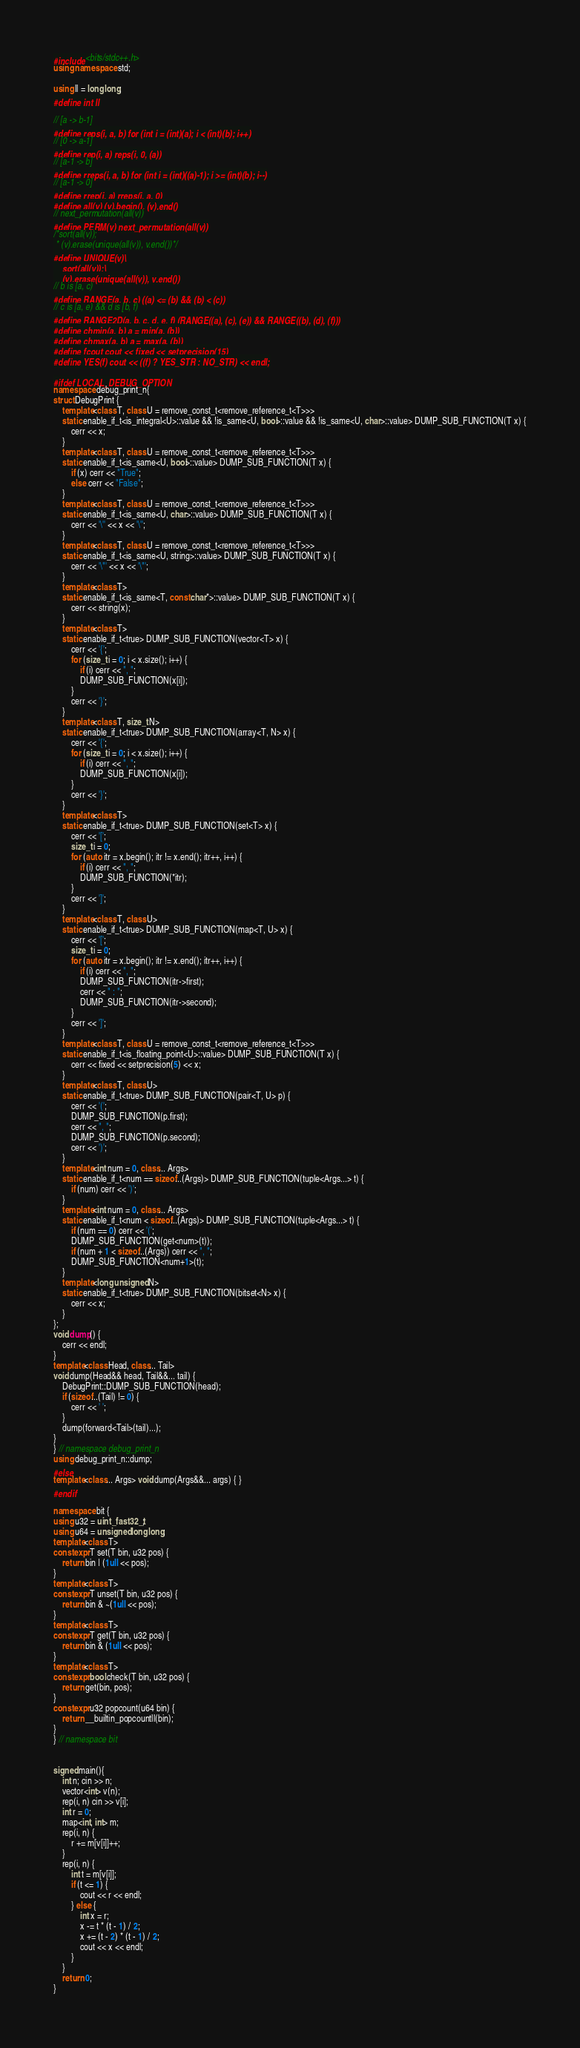Convert code to text. <code><loc_0><loc_0><loc_500><loc_500><_C++_>#include <bits/stdc++.h>
using namespace std;

using ll = long long;
#define int ll

// [a -> b-1]
#define reps(i, a, b) for (int i = (int)(a); i < (int)(b); i++)
// [0 -> a-1]
#define rep(i, a) reps(i, 0, (a))
// [a-1 -> b]
#define rreps(i, a, b) for (int i = (int)((a)-1); i >= (int)(b); i--)
// [a-1 -> 0]
#define rrep(i, a) rreps(i, a, 0)
#define all(v) (v).begin(), (v).end()
// next_permutation(all(v))
#define PERM(v) next_permutation(all(v))
/*sort(all(v));
 * (v).erase(unique(all(v)), v.end())*/
#define UNIQUE(v)\
	sort(all(v));\
	(v).erase(unique(all(v)), v.end())
// b is [a, c)
#define RANGE(a, b, c) ((a) <= (b) && (b) < (c))
// c is [a, e) && d is [b, f)
#define RANGE2D(a, b, c, d, e, f) (RANGE((a), (c), (e)) && RANGE((b), (d), (f)))
#define chmin(a, b) a = min(a, (b))
#define chmax(a, b) a = max(a, (b))
#define fcout cout << fixed << setprecision(15)
#define YES(f) cout << ((f) ? YES_STR : NO_STR) << endl;

#ifdef LOCAL_DEBUG_OPTION
namespace debug_print_n{
struct DebugPrint {
	template<class T, class U = remove_const_t<remove_reference_t<T>>>
	static enable_if_t<is_integral<U>::value && !is_same<U, bool>::value && !is_same<U, char>::value> DUMP_SUB_FUNCTION(T x) {
		cerr << x;
	}
	template<class T, class U = remove_const_t<remove_reference_t<T>>>
	static enable_if_t<is_same<U, bool>::value> DUMP_SUB_FUNCTION(T x) {
		if (x) cerr << "True";
		else cerr << "False";
	}
	template<class T, class U = remove_const_t<remove_reference_t<T>>>
	static enable_if_t<is_same<U, char>::value> DUMP_SUB_FUNCTION(T x) {
		cerr << '\'' << x << '\'';
	}
	template<class T, class U = remove_const_t<remove_reference_t<T>>>
	static enable_if_t<is_same<U, string>::value> DUMP_SUB_FUNCTION(T x) {
		cerr << '\"' << x << '\"';
	}
	template<class T>
	static enable_if_t<is_same<T, const char*>::value> DUMP_SUB_FUNCTION(T x) {
		cerr << string(x);
	}
	template<class T>
	static enable_if_t<true> DUMP_SUB_FUNCTION(vector<T> x) {
		cerr << '{';
		for (size_t i = 0; i < x.size(); i++) {
			if (i) cerr << ", ";
			DUMP_SUB_FUNCTION(x[i]);
		}
		cerr << '}';
	}
	template<class T, size_t N>
	static enable_if_t<true> DUMP_SUB_FUNCTION(array<T, N> x) {
		cerr << '{';
		for (size_t i = 0; i < x.size(); i++) {
			if (i) cerr << ", ";
			DUMP_SUB_FUNCTION(x[i]);
		}
		cerr << '}';
	}
	template<class T>
	static enable_if_t<true> DUMP_SUB_FUNCTION(set<T> x) {
		cerr << '[';
		size_t i = 0;
		for (auto itr = x.begin(); itr != x.end(); itr++, i++) {
			if (i) cerr << ", ";
			DUMP_SUB_FUNCTION(*itr);
		}
		cerr << ']';
	}
	template<class T, class U>
	static enable_if_t<true> DUMP_SUB_FUNCTION(map<T, U> x) {
		cerr << '[';
		size_t i = 0;
		for (auto itr = x.begin(); itr != x.end(); itr++, i++) {
			if (i) cerr << ", ";
			DUMP_SUB_FUNCTION(itr->first);
			cerr << " : ";
			DUMP_SUB_FUNCTION(itr->second);
		}
		cerr << ']';
	}
	template<class T, class U = remove_const_t<remove_reference_t<T>>>
	static enable_if_t<is_floating_point<U>::value> DUMP_SUB_FUNCTION(T x) {
		cerr << fixed << setprecision(5) << x;
	}
	template<class T, class U>
	static enable_if_t<true> DUMP_SUB_FUNCTION(pair<T, U> p) {
		cerr << '(';
		DUMP_SUB_FUNCTION(p.first);
		cerr << ", ";
		DUMP_SUB_FUNCTION(p.second);
		cerr << ')';
	}
	template<int num = 0, class... Args>
	static enable_if_t<num == sizeof...(Args)> DUMP_SUB_FUNCTION(tuple<Args...> t) {
		if (num) cerr << ')';
	}
	template<int num = 0, class... Args>
	static enable_if_t<num < sizeof...(Args)> DUMP_SUB_FUNCTION(tuple<Args...> t) {
		if (num == 0) cerr << '(';
		DUMP_SUB_FUNCTION(get<num>(t));
		if (num + 1 < sizeof...(Args)) cerr << ", ";
		DUMP_SUB_FUNCTION<num+1>(t);
	}
	template<long unsigned N>
	static enable_if_t<true> DUMP_SUB_FUNCTION(bitset<N> x) {
		cerr << x;
	}
};
void dump() {
	cerr << endl;
}
template<class Head, class... Tail>
void dump(Head&& head, Tail&&... tail) {
	DebugPrint::DUMP_SUB_FUNCTION(head);
	if (sizeof...(Tail) != 0) {
		cerr << ' ';
	}
	dump(forward<Tail>(tail)...);
}
} // namespace debug_print_n
using debug_print_n::dump;
#else
template<class... Args> void dump(Args&&... args) { }
#endif

namespace bit {
using u32 = uint_fast32_t;
using u64 = unsigned long long;
template<class T>
constexpr T set(T bin, u32 pos) {
	return bin | (1ull << pos);
}
template<class T>
constexpr T unset(T bin, u32 pos) {
	return bin & ~(1ull << pos);
}
template<class T>
constexpr T get(T bin, u32 pos) {
	return bin & (1ull << pos);
}
template<class T>
constexpr bool check(T bin, u32 pos) {
	return get(bin, pos);
}
constexpr u32 popcount(u64 bin) {
	return __builtin_popcountll(bin);
}
} // namespace bit


signed main(){
	int n; cin >> n;
	vector<int> v(n);
	rep(i, n) cin >> v[i];
	int r = 0;
	map<int, int> m;
	rep(i, n) {
		r += m[v[i]]++;
	}
	rep(i, n) {
		int t = m[v[i]];
		if (t <= 1) {
			cout << r << endl;
		} else {
			int x = r;
			x -= t * (t - 1) / 2;
			x += (t - 2) * (t - 1) / 2;
			cout << x << endl;
		}
	}
	return 0;
}
</code> 